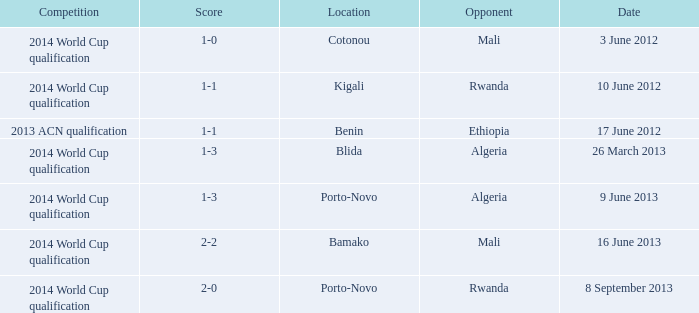What competition is located in bamako? 2014 World Cup qualification. 